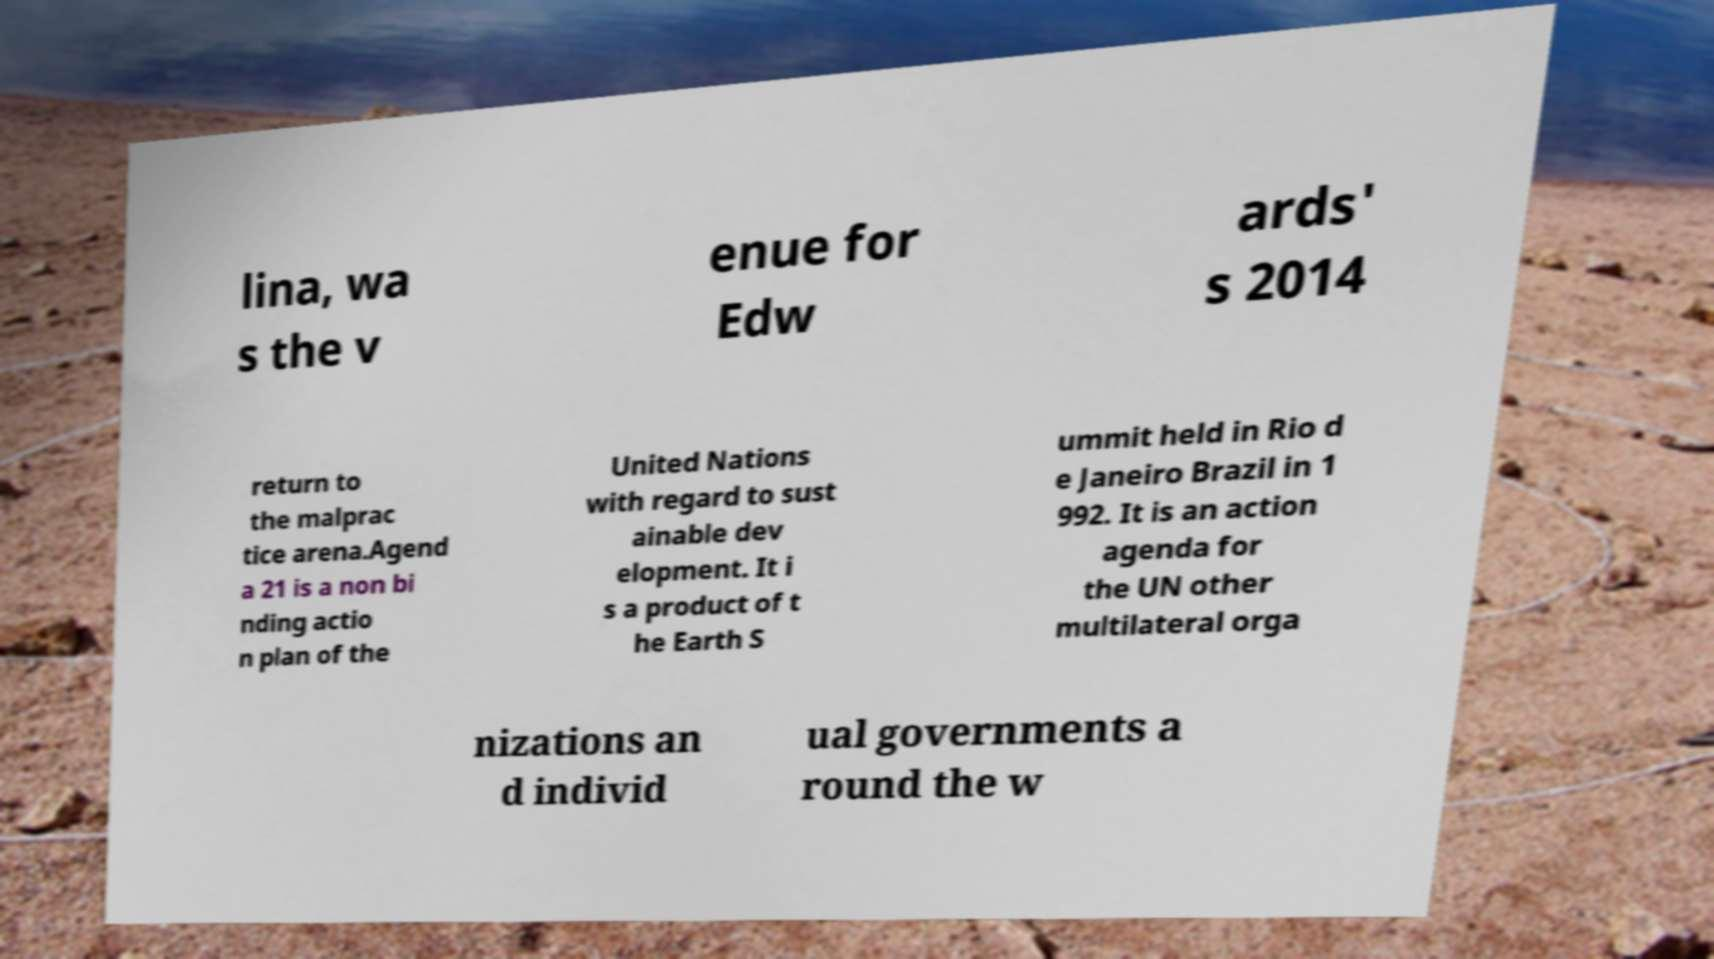Could you assist in decoding the text presented in this image and type it out clearly? lina, wa s the v enue for Edw ards' s 2014 return to the malprac tice arena.Agend a 21 is a non bi nding actio n plan of the United Nations with regard to sust ainable dev elopment. It i s a product of t he Earth S ummit held in Rio d e Janeiro Brazil in 1 992. It is an action agenda for the UN other multilateral orga nizations an d individ ual governments a round the w 